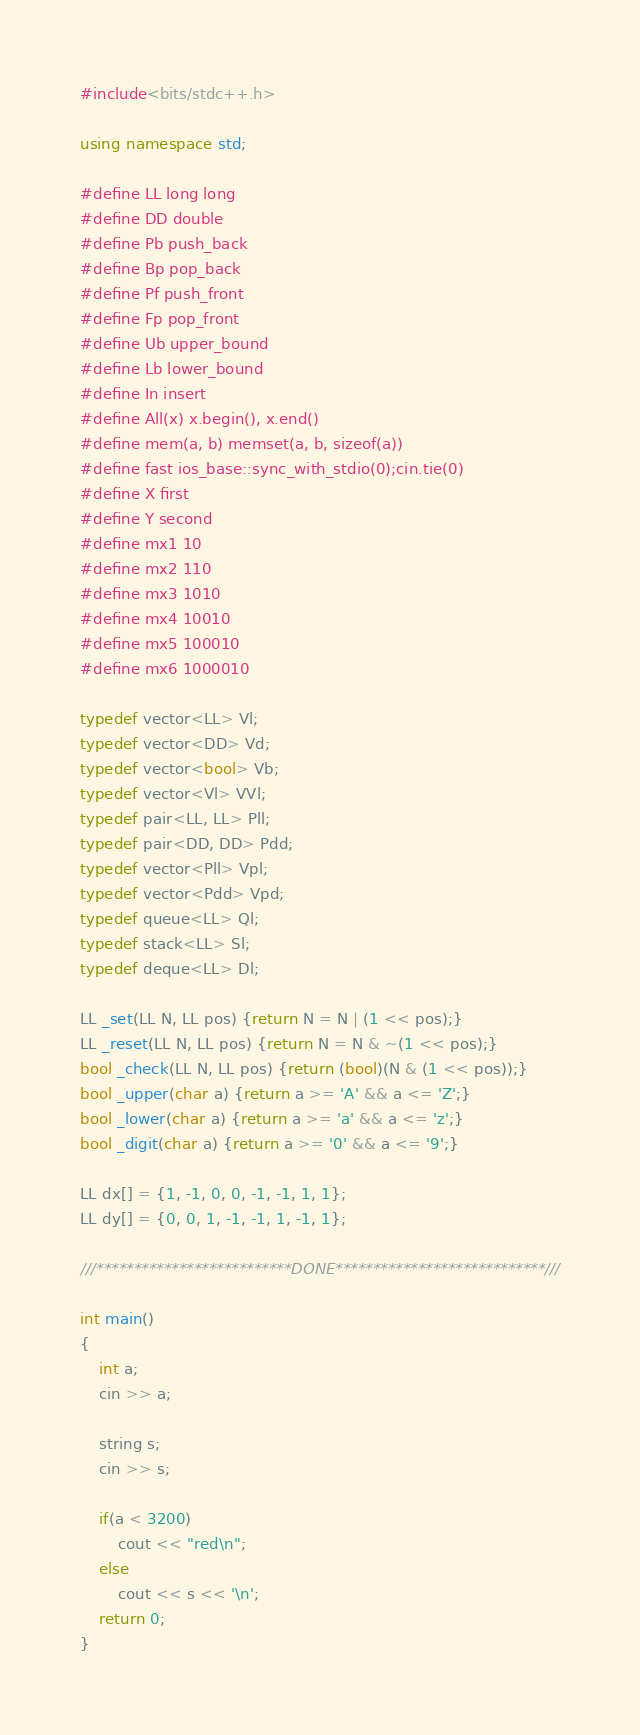<code> <loc_0><loc_0><loc_500><loc_500><_C++_>#include<bits/stdc++.h>

using namespace std;

#define LL long long
#define DD double
#define Pb push_back
#define Bp pop_back
#define Pf push_front
#define Fp pop_front
#define Ub upper_bound
#define Lb lower_bound
#define In insert
#define All(x) x.begin(), x.end()
#define mem(a, b) memset(a, b, sizeof(a))
#define fast ios_base::sync_with_stdio(0);cin.tie(0)
#define X first
#define Y second
#define mx1 10
#define mx2 110
#define mx3 1010
#define mx4 10010
#define mx5 100010
#define mx6 1000010

typedef vector<LL> Vl;
typedef vector<DD> Vd;
typedef vector<bool> Vb;
typedef vector<Vl> VVl;
typedef pair<LL, LL> Pll;
typedef pair<DD, DD> Pdd;
typedef vector<Pll> Vpl;
typedef vector<Pdd> Vpd;
typedef queue<LL> Ql;
typedef stack<LL> Sl;
typedef deque<LL> Dl;

LL _set(LL N, LL pos) {return N = N | (1 << pos);}
LL _reset(LL N, LL pos) {return N = N & ~(1 << pos);}
bool _check(LL N, LL pos) {return (bool)(N & (1 << pos));}
bool _upper(char a) {return a >= 'A' && a <= 'Z';}
bool _lower(char a) {return a >= 'a' && a <= 'z';}
bool _digit(char a) {return a >= '0' && a <= '9';}

LL dx[] = {1, -1, 0, 0, -1, -1, 1, 1};
LL dy[] = {0, 0, 1, -1, -1, 1, -1, 1};

///**************************DONE****************************///

int main()
{
    int a;
    cin >> a;

    string s;
    cin >> s;

    if(a < 3200)
        cout << "red\n";
    else
        cout << s << '\n';
    return 0;
}</code> 